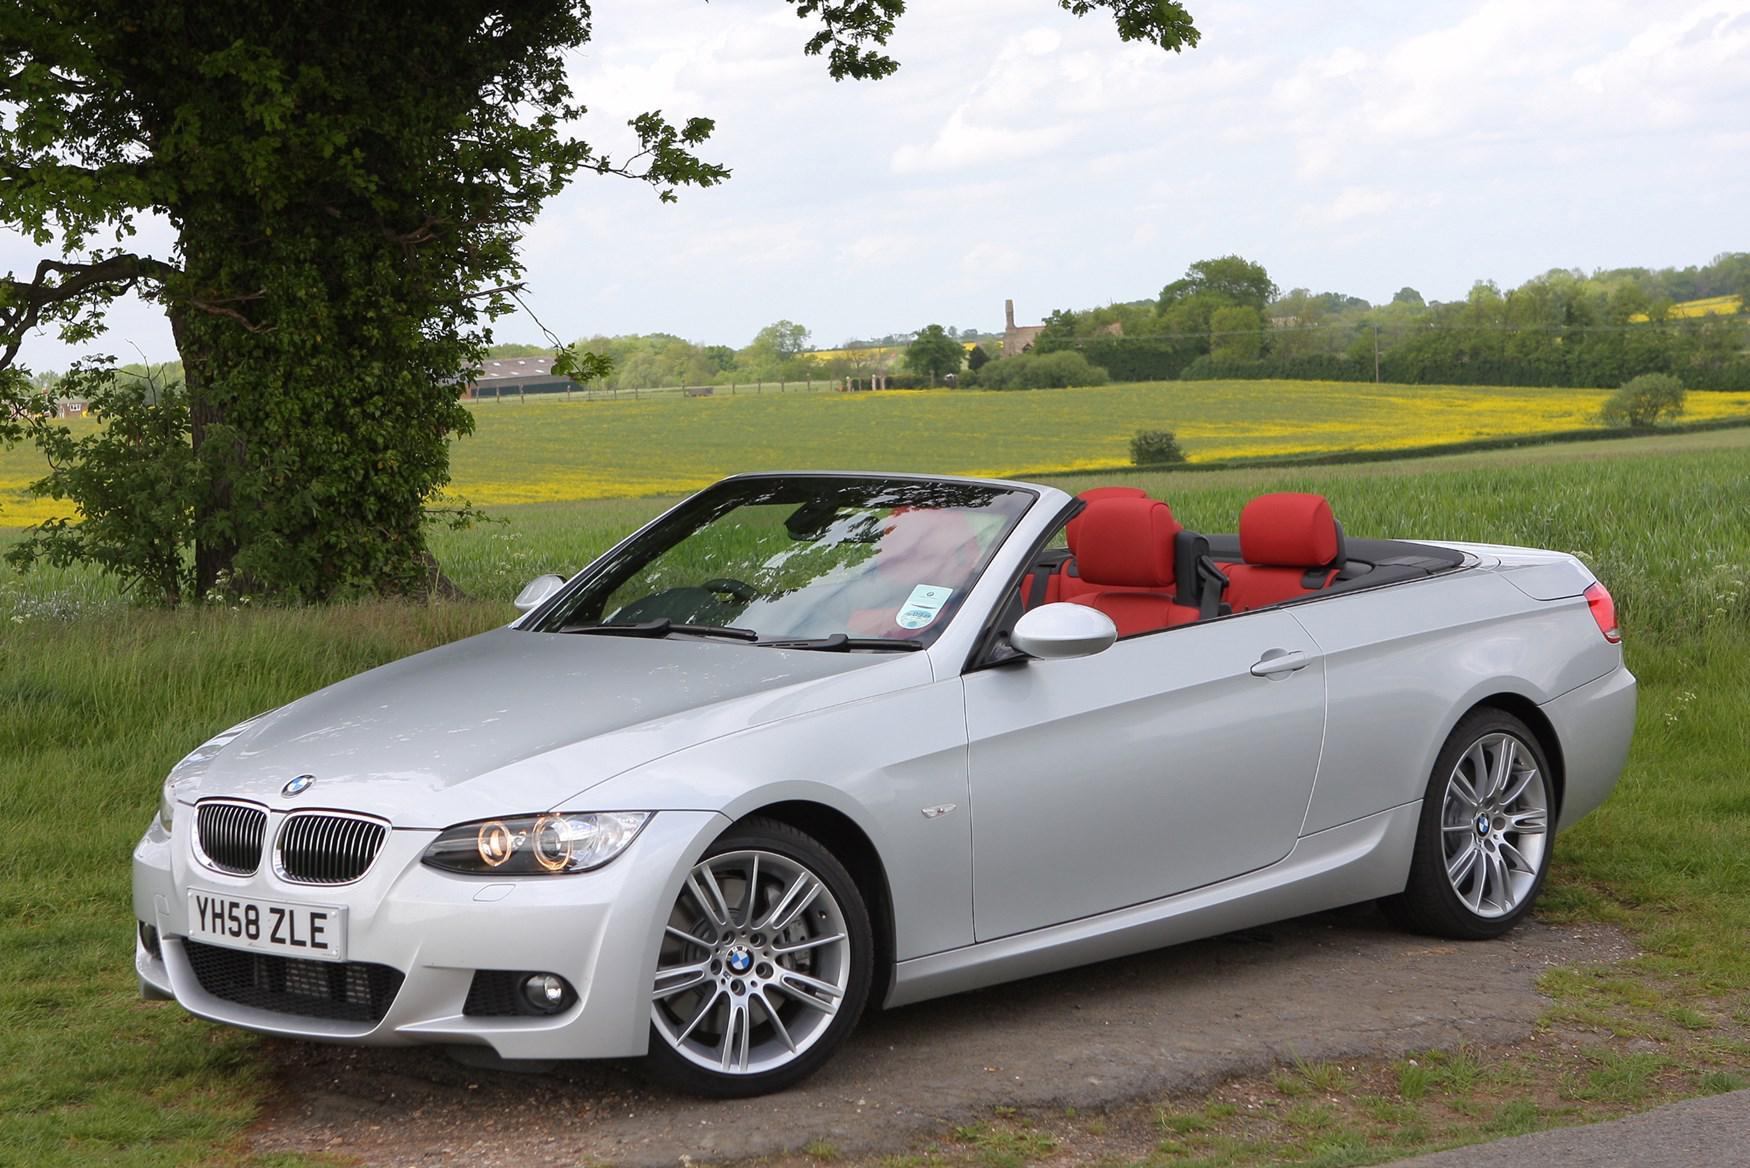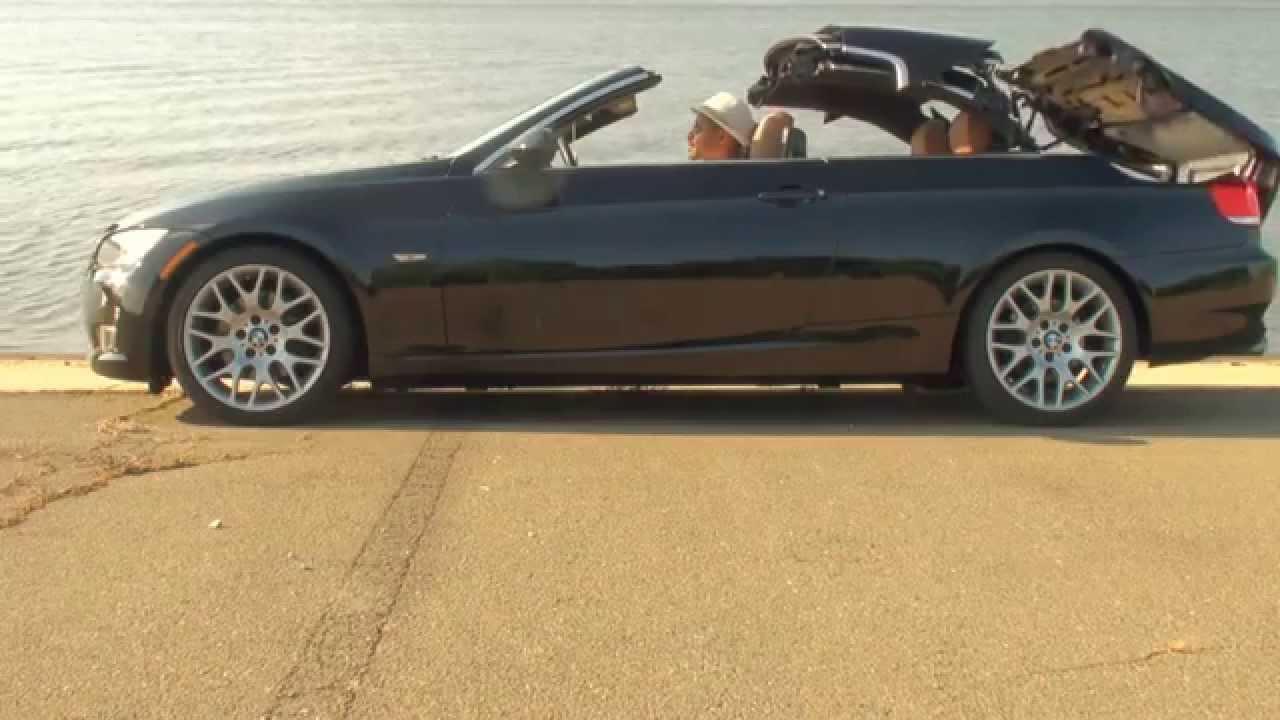The first image is the image on the left, the second image is the image on the right. Examine the images to the left and right. Is the description "In one of the images, the top of the convertible car is in the middle of coming up or down" accurate? Answer yes or no. Yes. 